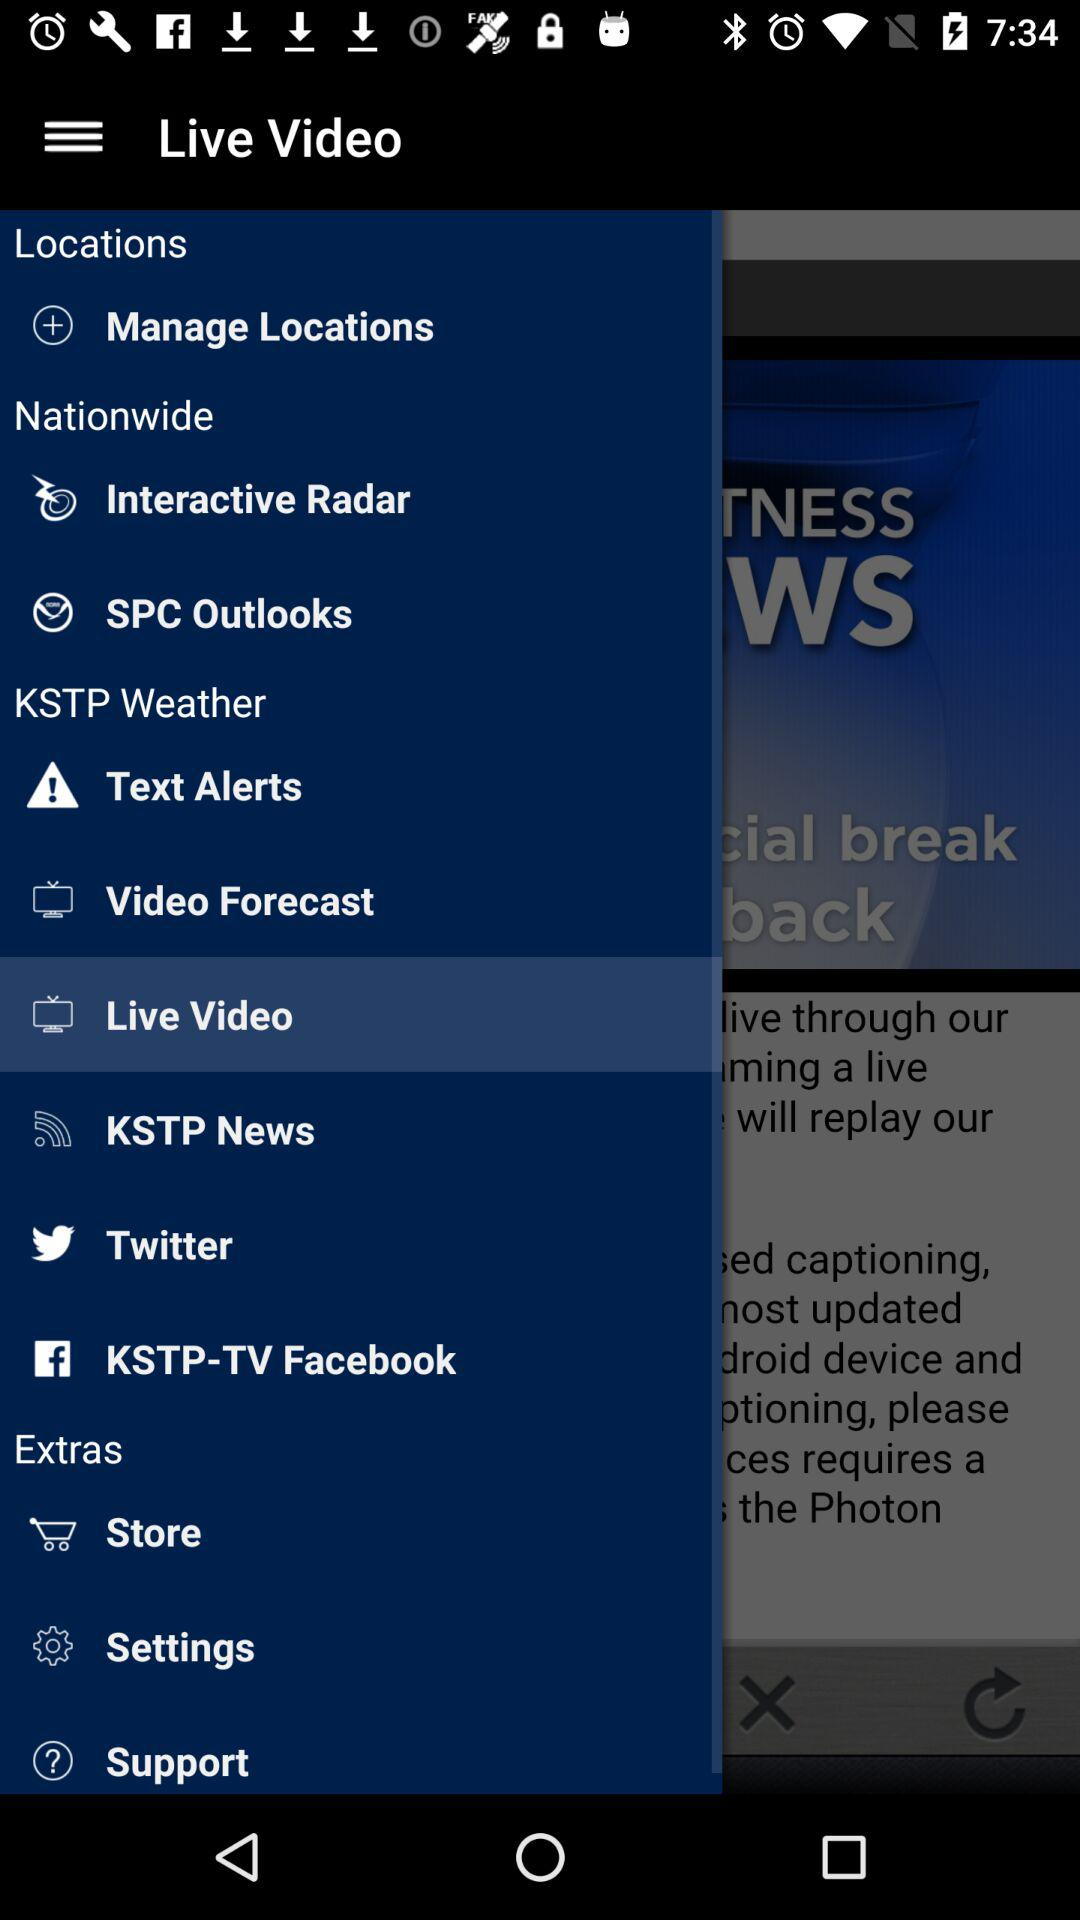What is the selected item in "KSTP Weather"? The selected item is "Live Video". 